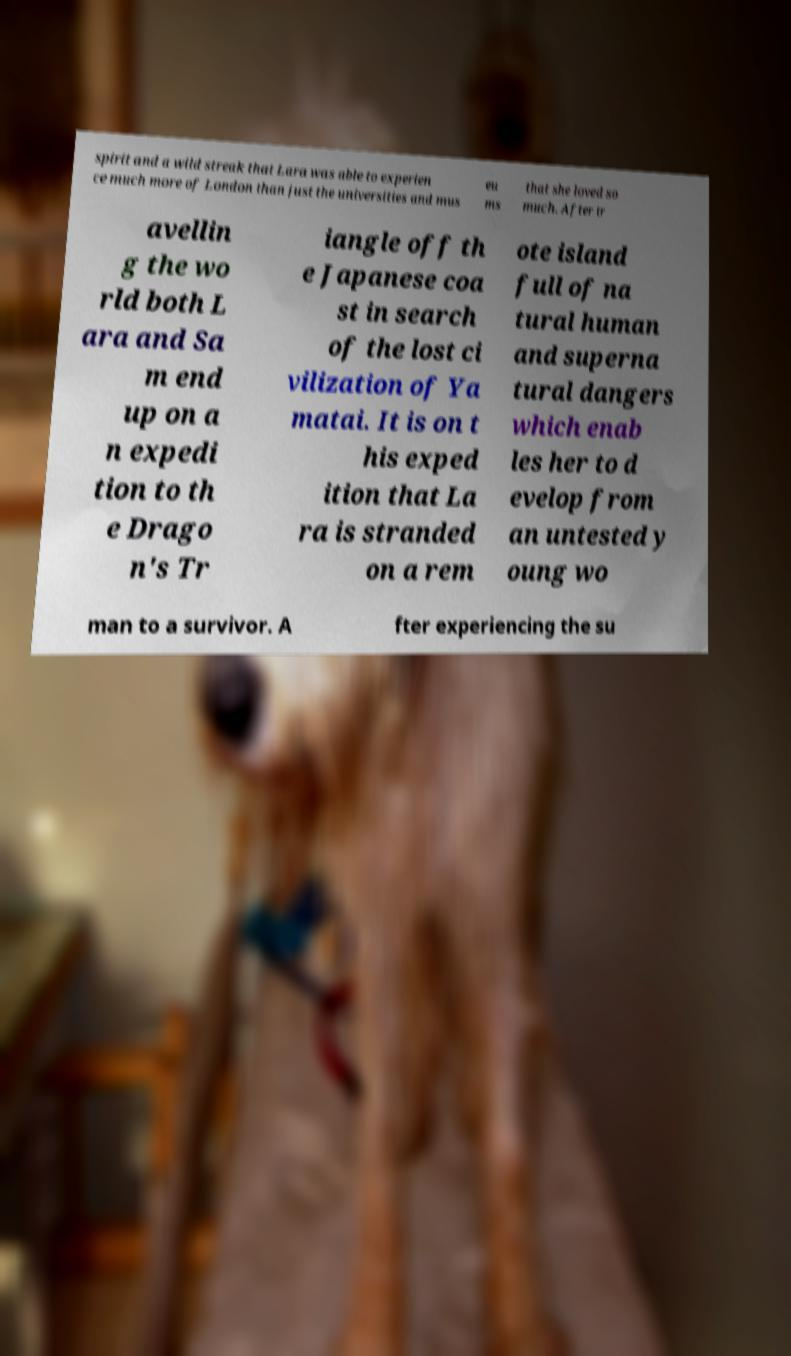For documentation purposes, I need the text within this image transcribed. Could you provide that? spirit and a wild streak that Lara was able to experien ce much more of London than just the universities and mus eu ms that she loved so much. After tr avellin g the wo rld both L ara and Sa m end up on a n expedi tion to th e Drago n's Tr iangle off th e Japanese coa st in search of the lost ci vilization of Ya matai. It is on t his exped ition that La ra is stranded on a rem ote island full of na tural human and superna tural dangers which enab les her to d evelop from an untested y oung wo man to a survivor. A fter experiencing the su 